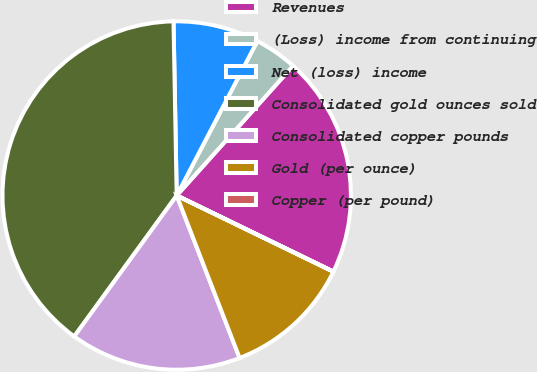<chart> <loc_0><loc_0><loc_500><loc_500><pie_chart><fcel>Revenues<fcel>(Loss) income from continuing<fcel>Net (loss) income<fcel>Consolidated gold ounces sold<fcel>Consolidated copper pounds<fcel>Gold (per ounce)<fcel>Copper (per pound)<nl><fcel>20.56%<fcel>3.98%<fcel>7.95%<fcel>39.71%<fcel>15.89%<fcel>11.92%<fcel>0.01%<nl></chart> 